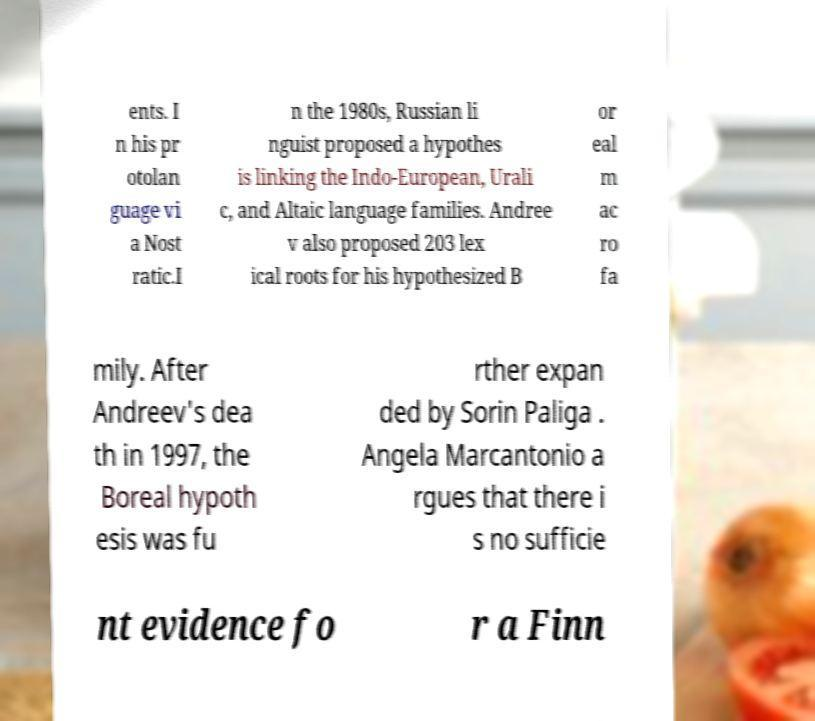Please identify and transcribe the text found in this image. ents. I n his pr otolan guage vi a Nost ratic.I n the 1980s, Russian li nguist proposed a hypothes is linking the Indo-European, Urali c, and Altaic language families. Andree v also proposed 203 lex ical roots for his hypothesized B or eal m ac ro fa mily. After Andreev's dea th in 1997, the Boreal hypoth esis was fu rther expan ded by Sorin Paliga . Angela Marcantonio a rgues that there i s no sufficie nt evidence fo r a Finn 